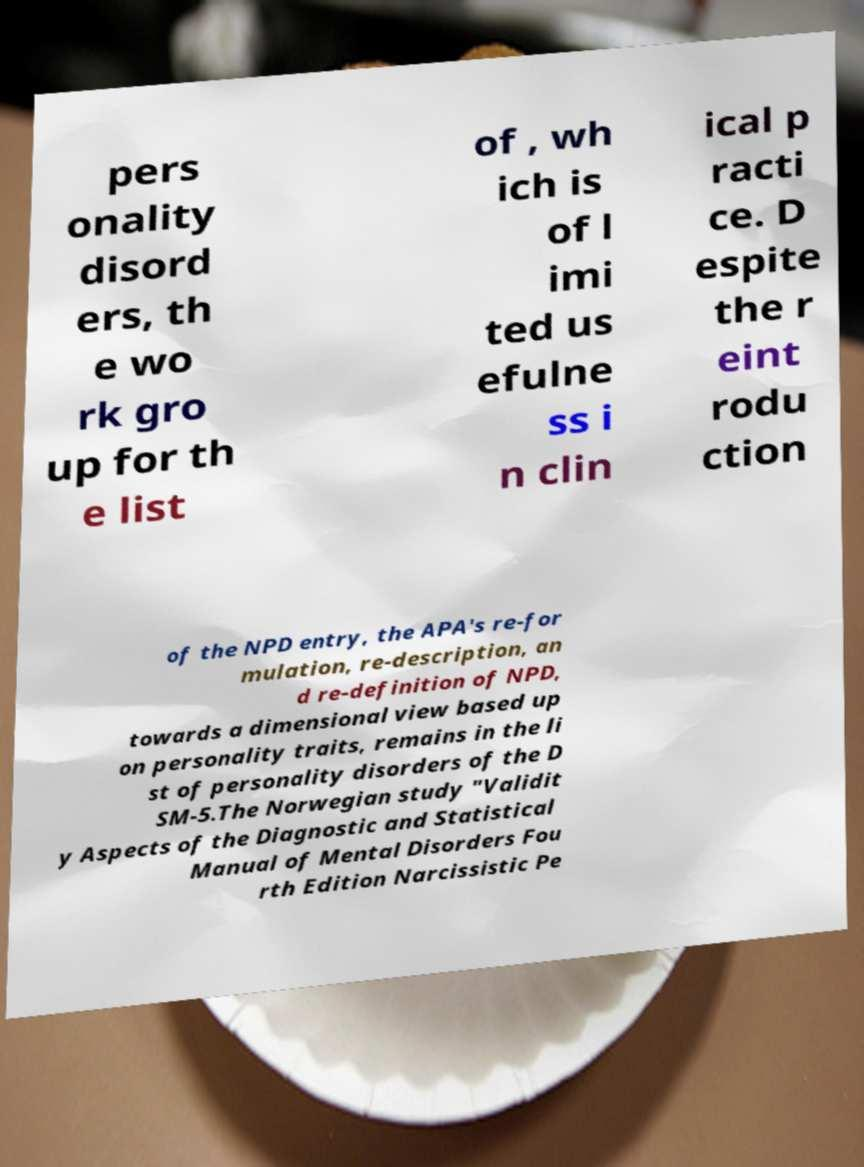Could you assist in decoding the text presented in this image and type it out clearly? pers onality disord ers, th e wo rk gro up for th e list of , wh ich is of l imi ted us efulne ss i n clin ical p racti ce. D espite the r eint rodu ction of the NPD entry, the APA's re-for mulation, re-description, an d re-definition of NPD, towards a dimensional view based up on personality traits, remains in the li st of personality disorders of the D SM-5.The Norwegian study "Validit y Aspects of the Diagnostic and Statistical Manual of Mental Disorders Fou rth Edition Narcissistic Pe 